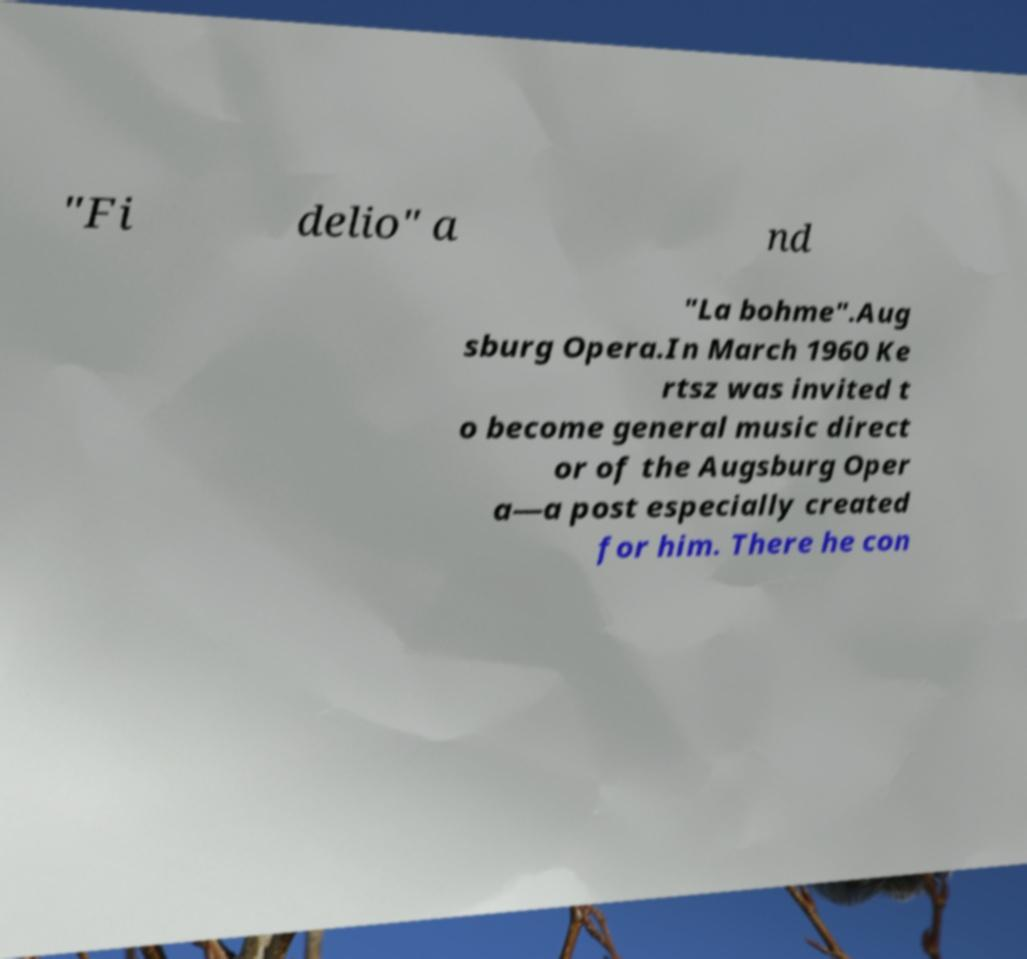Could you extract and type out the text from this image? "Fi delio" a nd "La bohme".Aug sburg Opera.In March 1960 Ke rtsz was invited t o become general music direct or of the Augsburg Oper a—a post especially created for him. There he con 